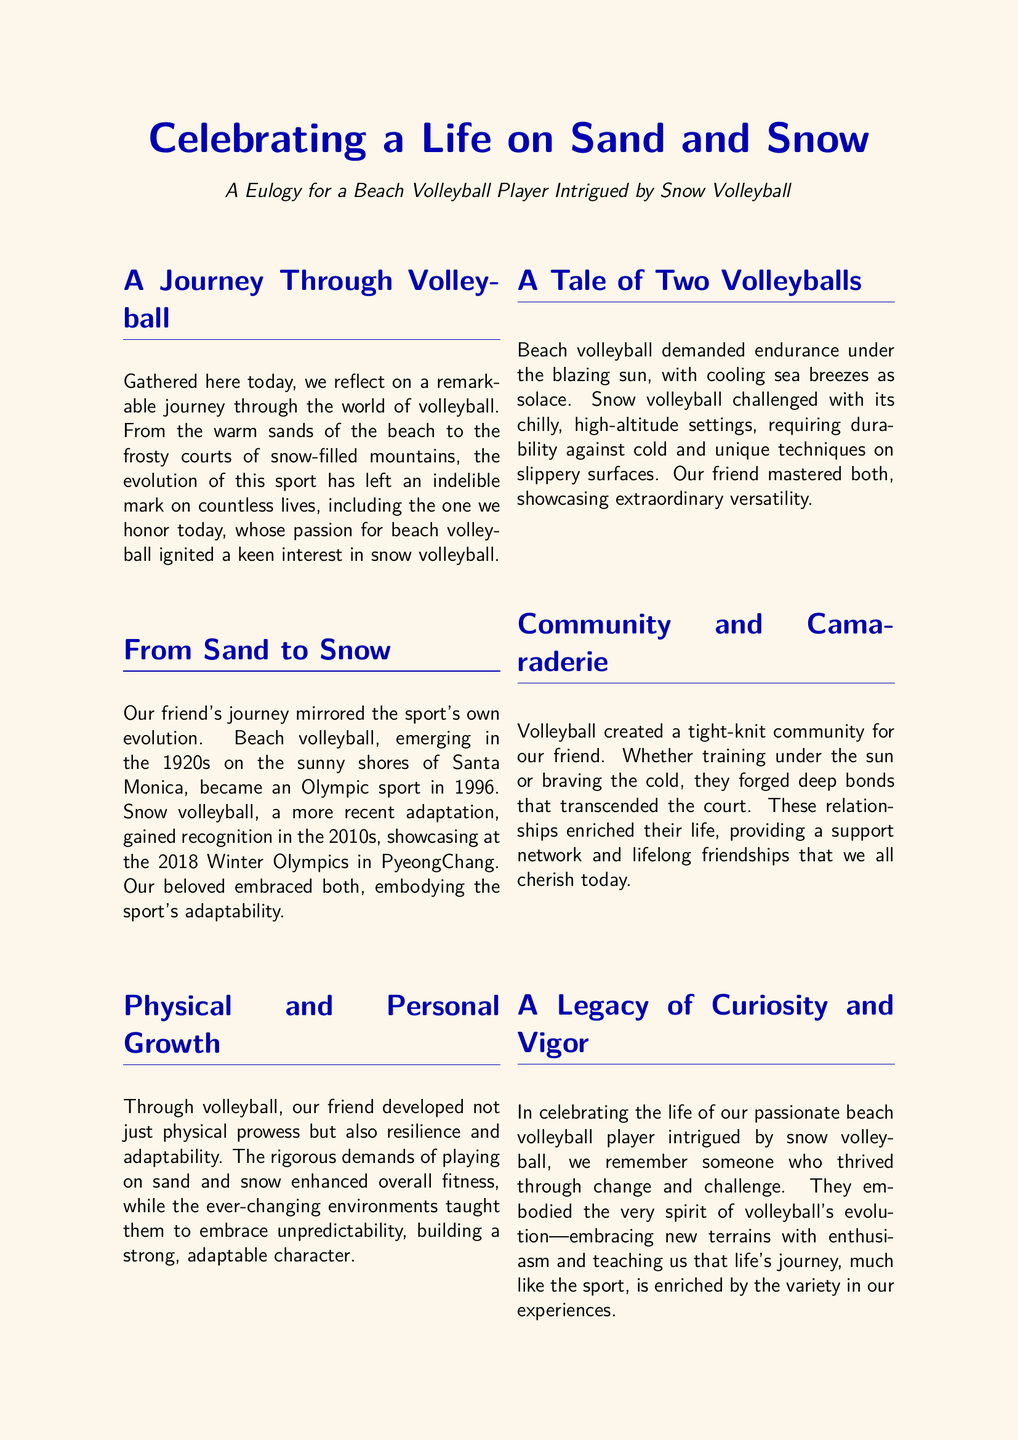what sport became an Olympic event in 1996? The document states that beach volleyball became an Olympic sport in 1996.
Answer: beach volleyball when did snow volleyball gain recognition? The document mentions that snow volleyball gained recognition in the 2010s.
Answer: 2010s what does beach volleyball demand according to the eulogy? The eulogy states that beach volleyball demanded endurance under the blazing sun.
Answer: endurance which type of volleyball was highlighted for its chilly settings? The document emphasizes snow volleyball for its chilly, high-altitude settings.
Answer: snow volleyball what aspect of volleyball did our friend embrace that reflects their character? The document notes that they learned to embrace unpredictability, reflecting adaptability.
Answer: unpredictability how did volleyball impact our friend's personal relationships? It created a tight-knit community that provided lifelong friendships.
Answer: community what does the eulogy suggest about the spirit of volleyball? It suggests that the spirit of volleyball is about embracing change and challenge.
Answer: embracing change what metaphor is used to describe life in the eulogy? The eulogy uses the metaphor that life, like volleyball, is best played with passion.
Answer: passion 